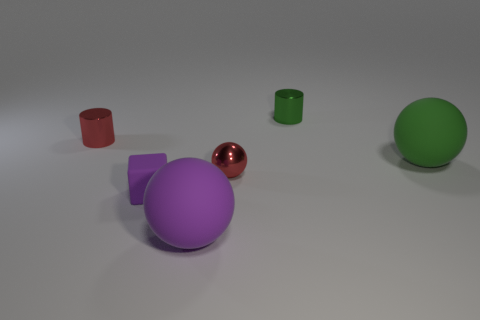Add 3 small red cylinders. How many objects exist? 9 Subtract all cylinders. How many objects are left? 4 Subtract all green cylinders. Subtract all small red cylinders. How many objects are left? 4 Add 1 purple matte objects. How many purple matte objects are left? 3 Add 3 small green cylinders. How many small green cylinders exist? 4 Subtract 0 cyan cubes. How many objects are left? 6 